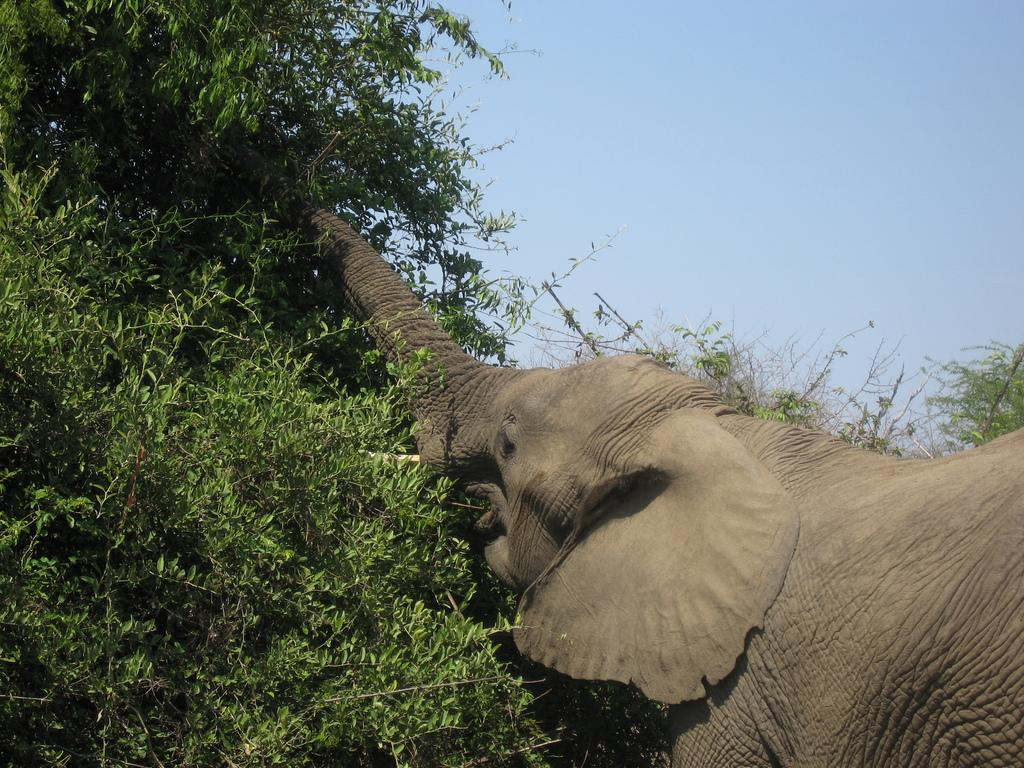What animal is the main subject of the image? There is an elephant in the image. What can be seen in the background behind the elephant? There are trees behind the elephant. What is visible at the top of the image? The sky is visible at the top of the image. What type of twig is the elephant holding in its trunk in the image? There is no twig present in the image; the elephant is not holding anything in its trunk. How many ducks can be seen swimming in the water near the elephant in the image? There are no ducks present in the image; the focus is on the elephant and the trees in the background. 